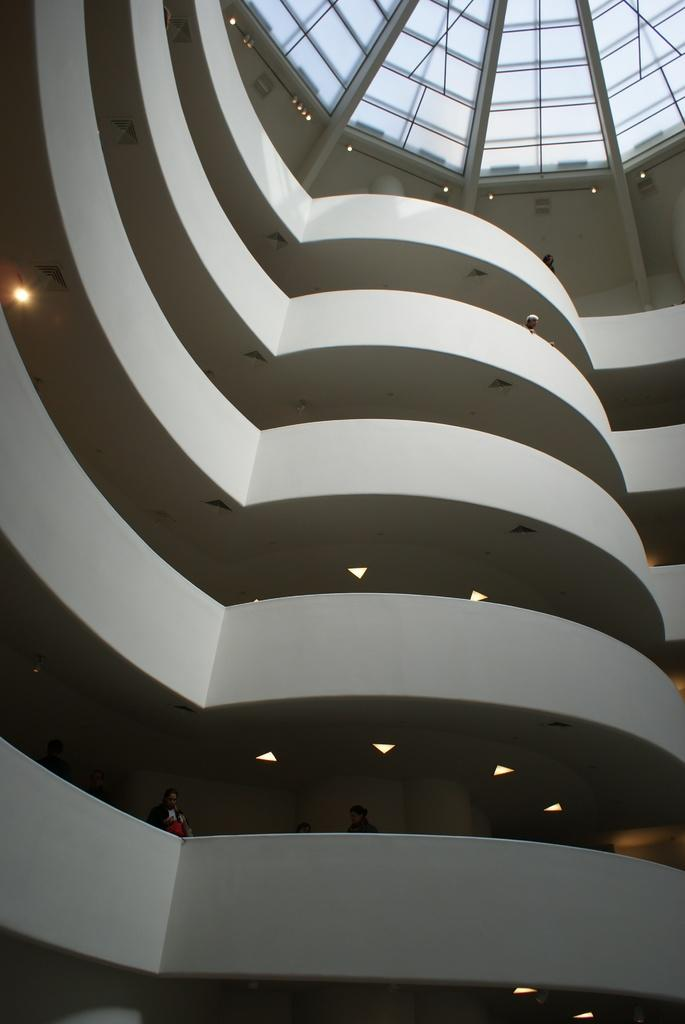What type of location is depicted in the image? The image shows the interior of a building. How many floors are visible in the image? There are multiple floors in the building. What features are present on each floor? Each floor has walls and lights. Are there any people inside the building? Yes, there are people inside the building. What can be seen on the ceiling of the building? The ceiling has glass roofs and lights. What direction is the current flowing in the image? There is no reference to a current or water in the image, so it is not possible to determine the direction of any current. 